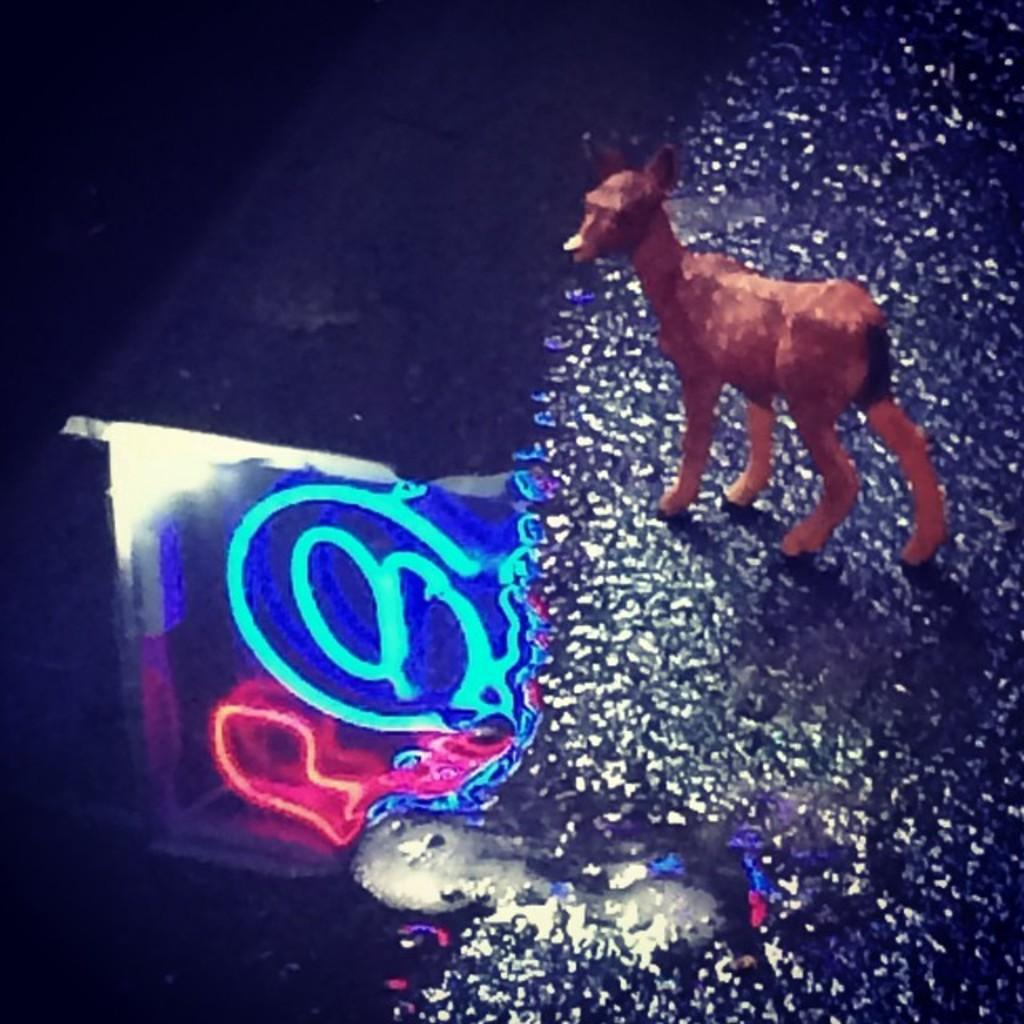What type of object is the main subject in the image? There is a statue of an animal in the image. Can you describe the appearance of the object on the left side of the image? There is a colorful object on the left side of the image. What type of texture can be seen on the beds in the image? There are no beds present in the image; it features a statue of an animal and a colorful object. 